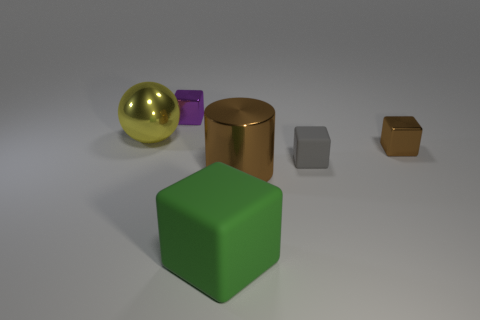There is a cube in front of the gray matte block; how many large shiny balls are in front of it?
Make the answer very short. 0. What size is the metallic object that is to the right of the big block and behind the brown metal cylinder?
Give a very brief answer. Small. Are there any purple things that have the same size as the cylinder?
Your answer should be very brief. No. Is the number of tiny brown things on the right side of the green matte block greater than the number of big blocks that are behind the large brown cylinder?
Give a very brief answer. Yes. Do the purple thing and the tiny thing in front of the brown shiny cube have the same material?
Give a very brief answer. No. How many small metal things are to the left of the brown metallic thing that is left of the tiny metallic cube to the right of the big cylinder?
Keep it short and to the point. 1. There is a big matte object; is it the same shape as the small shiny thing that is to the left of the large cylinder?
Offer a very short reply. Yes. The block that is both left of the gray cube and in front of the shiny ball is what color?
Offer a very short reply. Green. The large thing that is in front of the brown thing in front of the rubber thing behind the brown metal cylinder is made of what material?
Your answer should be compact. Rubber. What material is the big green cube?
Offer a very short reply. Rubber. 